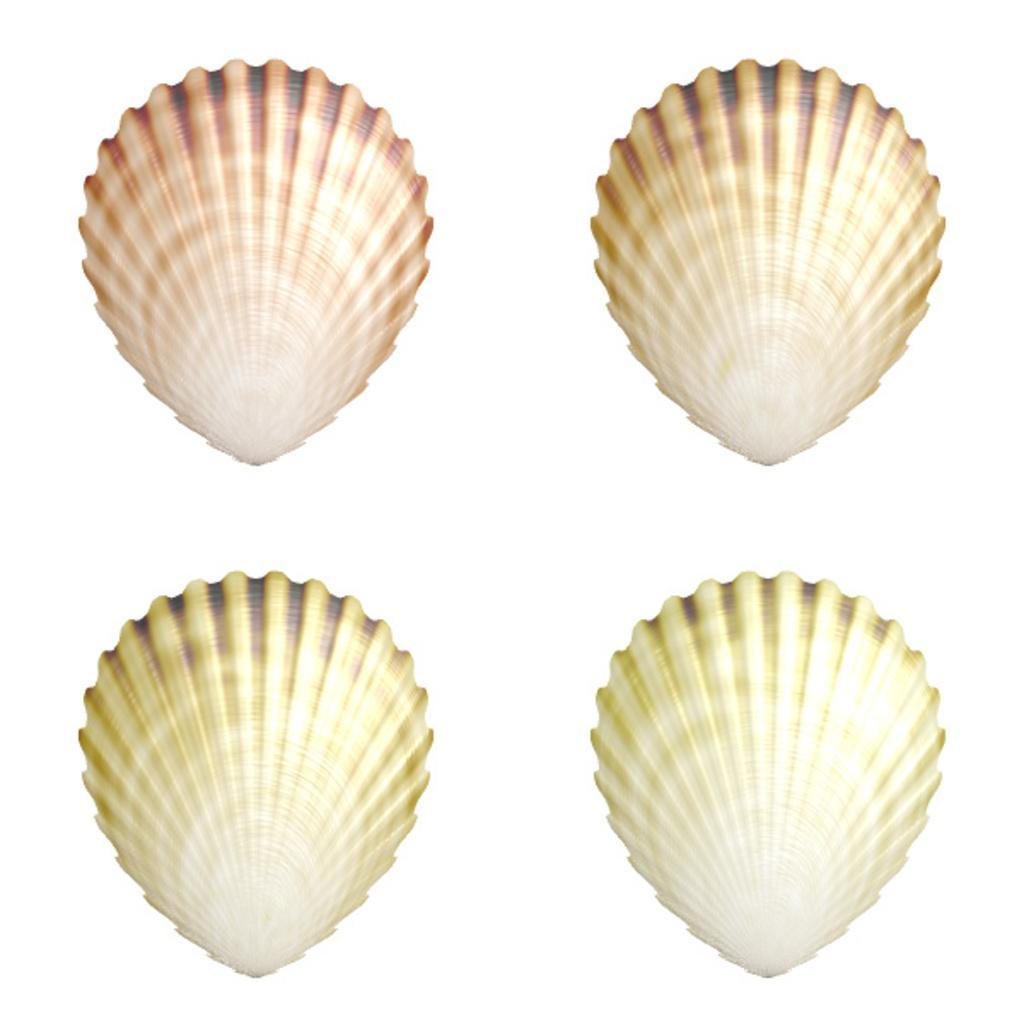How would you summarize this image in a sentence or two? There are four shells. In the background there is white color. 